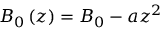<formula> <loc_0><loc_0><loc_500><loc_500>B _ { 0 } \left ( z \right ) = B _ { 0 } - a z ^ { 2 }</formula> 